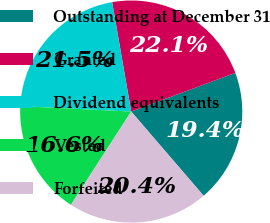Convert chart. <chart><loc_0><loc_0><loc_500><loc_500><pie_chart><fcel>Outstanding at December 31<fcel>Granted<fcel>Dividend equivalents<fcel>Vested<fcel>Forfeited<nl><fcel>19.36%<fcel>22.08%<fcel>21.48%<fcel>16.65%<fcel>20.43%<nl></chart> 